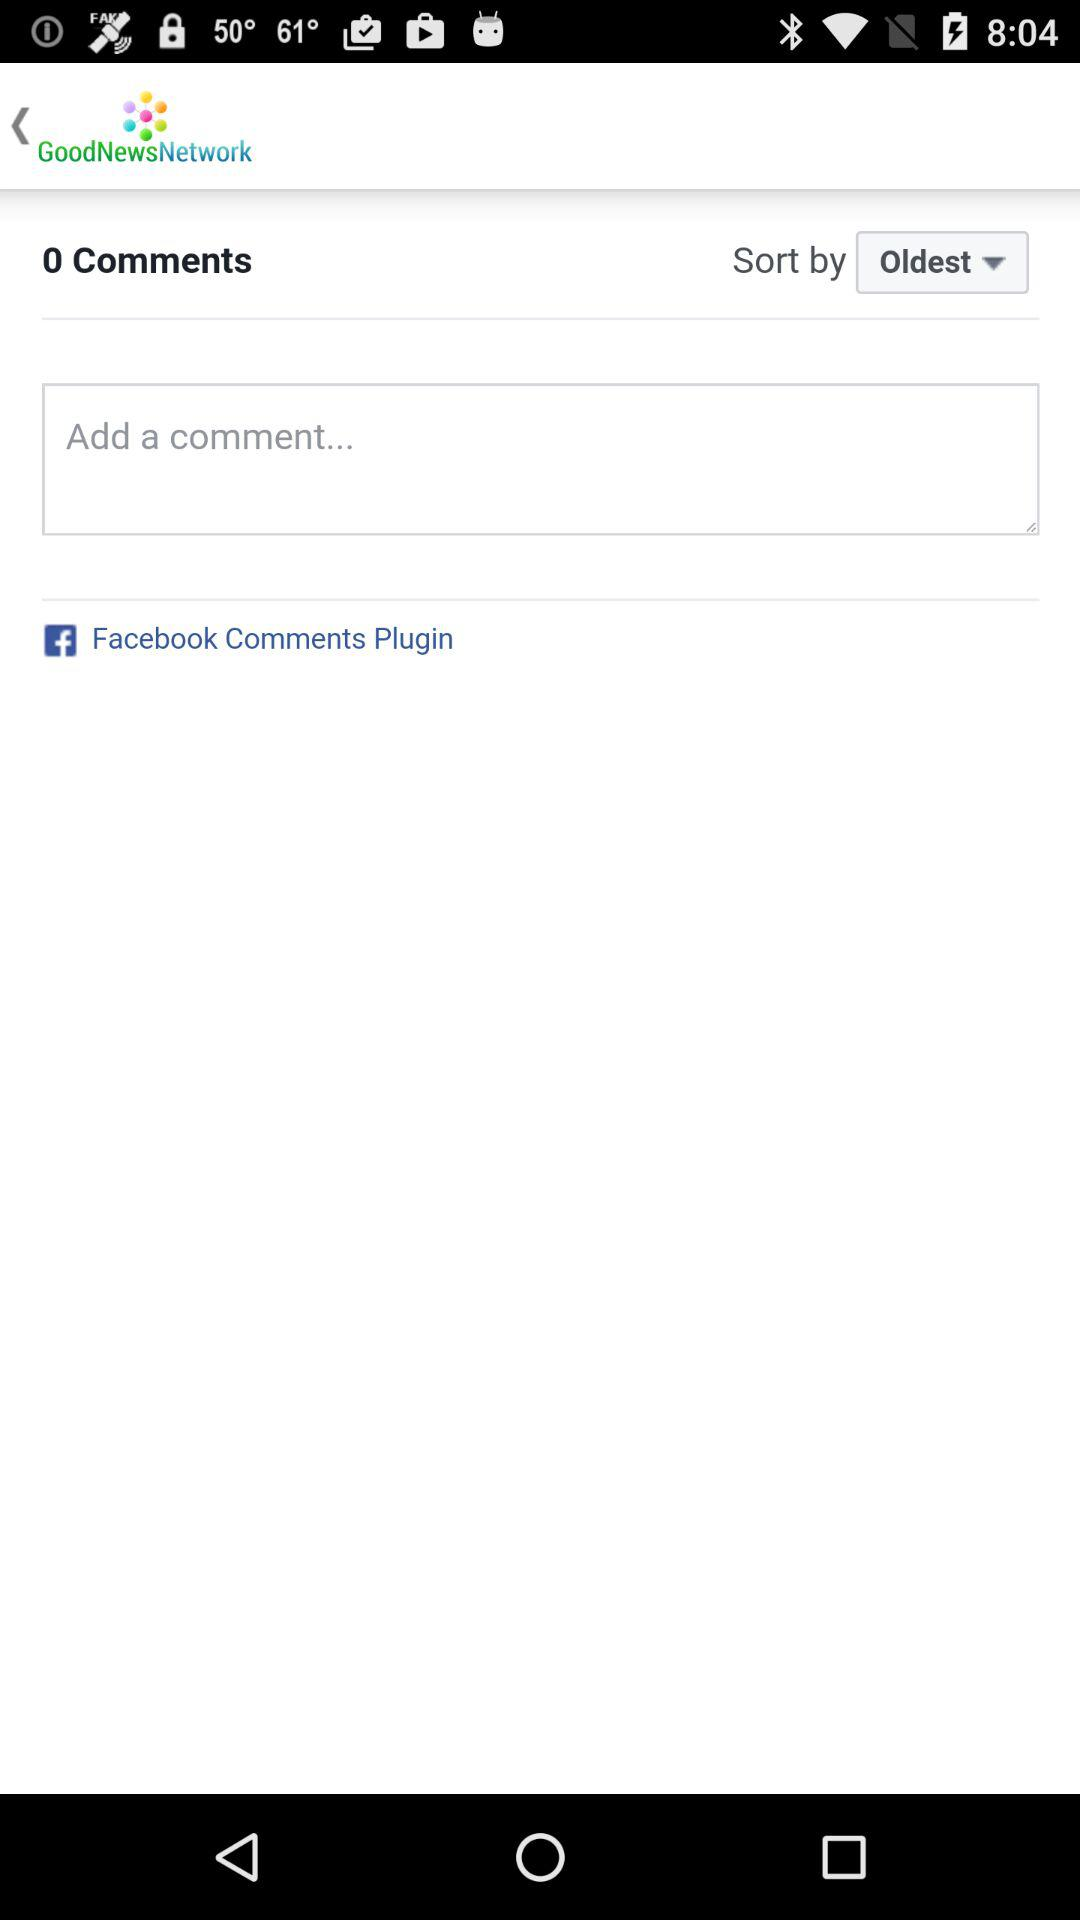Which "Sort by" option is selected? The selected option is "Oldest". 